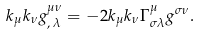<formula> <loc_0><loc_0><loc_500><loc_500>k _ { \mu } k _ { \nu } g ^ { \mu \nu } _ { , \, \lambda } = - 2 k _ { \mu } k _ { \nu } \Gamma ^ { \mu } _ { \sigma \lambda } g ^ { \sigma \nu } .</formula> 